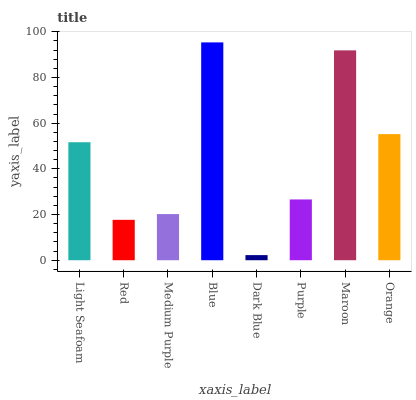Is Dark Blue the minimum?
Answer yes or no. Yes. Is Blue the maximum?
Answer yes or no. Yes. Is Red the minimum?
Answer yes or no. No. Is Red the maximum?
Answer yes or no. No. Is Light Seafoam greater than Red?
Answer yes or no. Yes. Is Red less than Light Seafoam?
Answer yes or no. Yes. Is Red greater than Light Seafoam?
Answer yes or no. No. Is Light Seafoam less than Red?
Answer yes or no. No. Is Light Seafoam the high median?
Answer yes or no. Yes. Is Purple the low median?
Answer yes or no. Yes. Is Red the high median?
Answer yes or no. No. Is Medium Purple the low median?
Answer yes or no. No. 